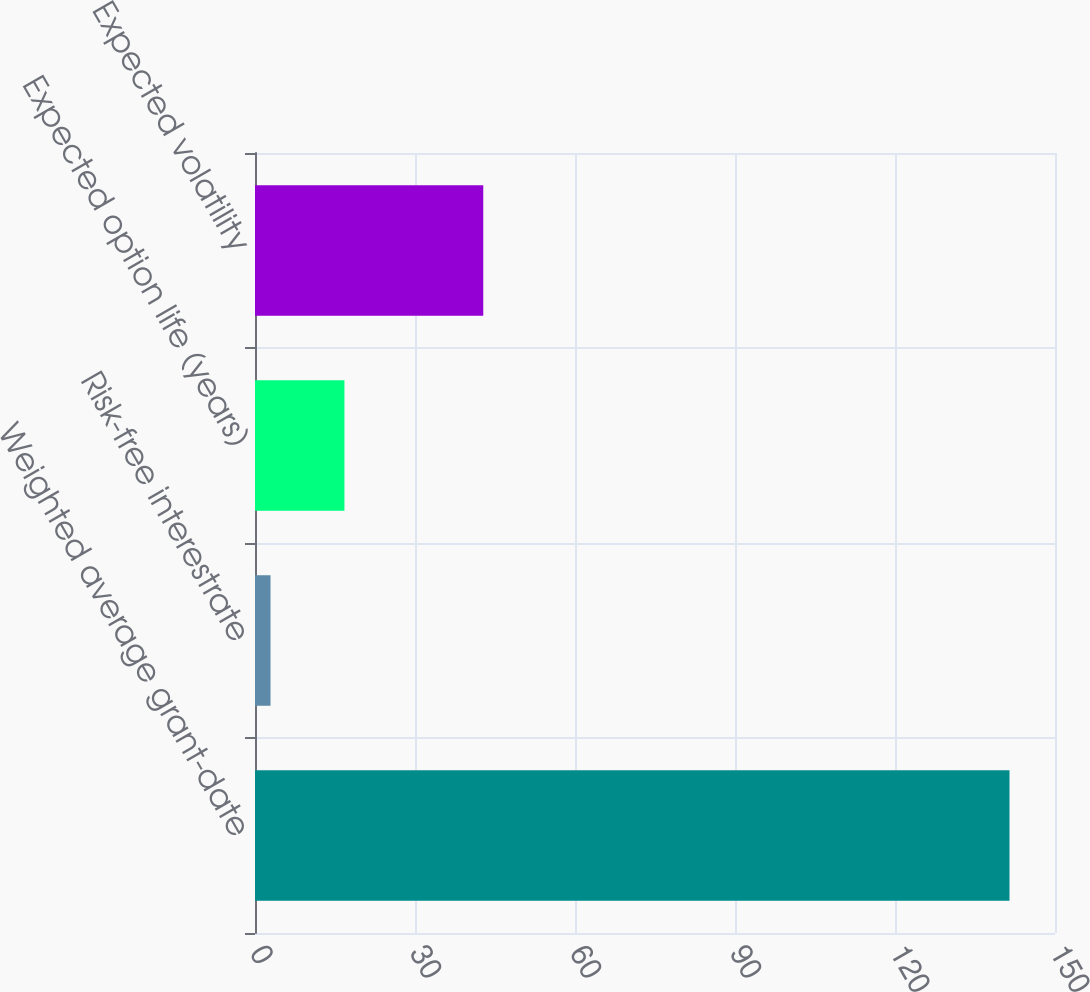<chart> <loc_0><loc_0><loc_500><loc_500><bar_chart><fcel>Weighted average grant-date<fcel>Risk-free interestrate<fcel>Expected option life (years)<fcel>Expected volatility<nl><fcel>141.47<fcel>2.91<fcel>16.77<fcel>42.8<nl></chart> 